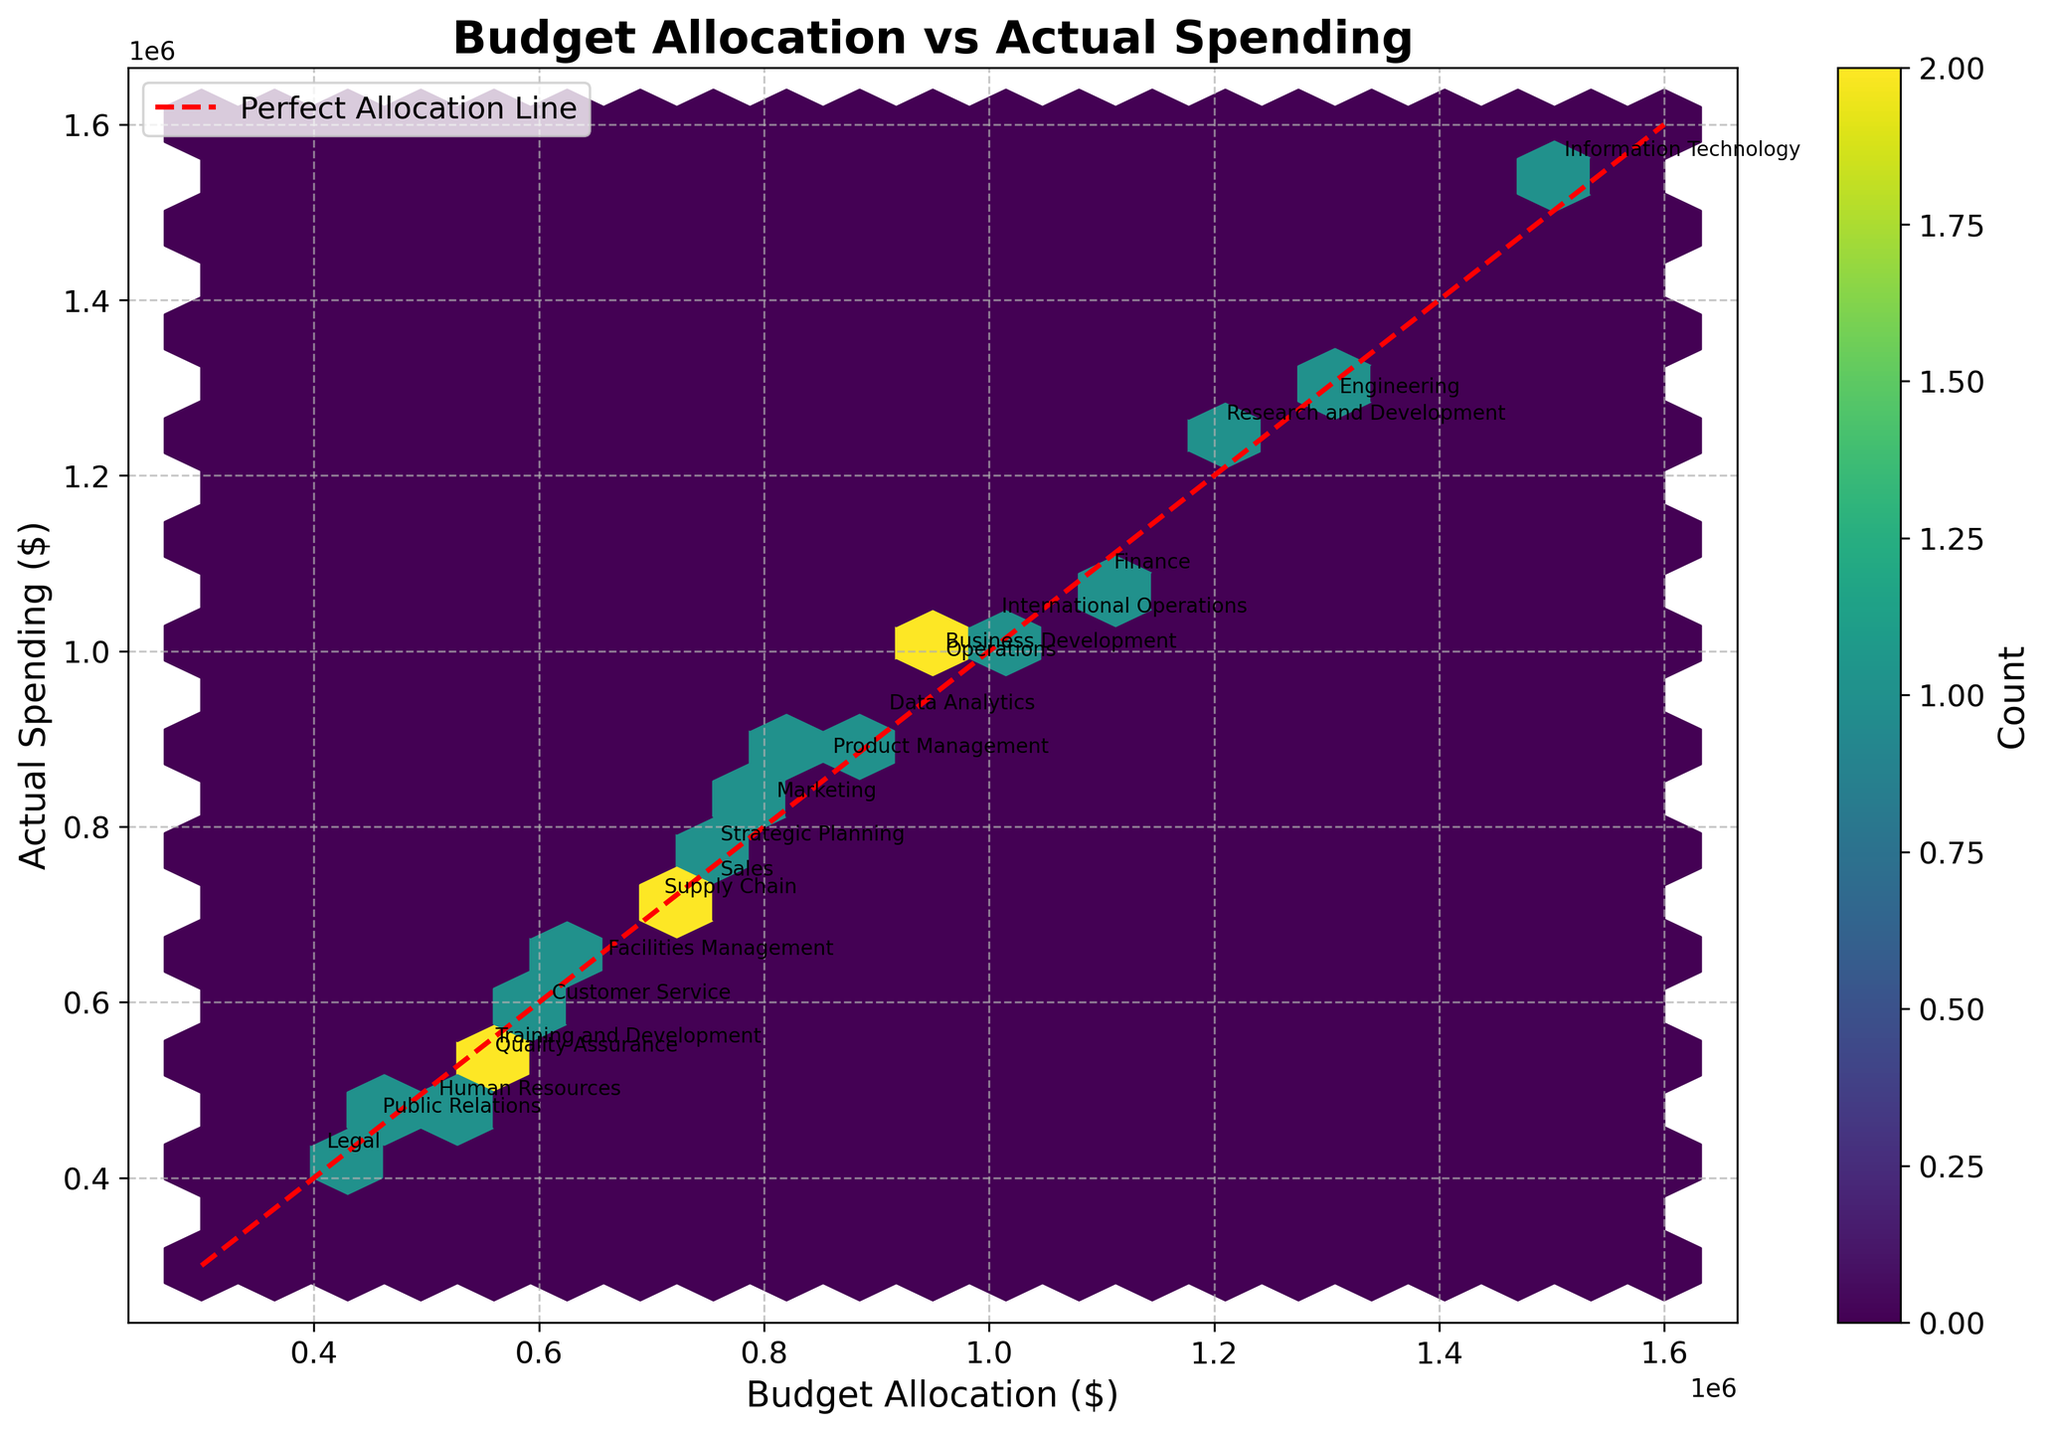What is the title of the plot? The title is displayed at the top of the figure. It provides context about the data being visualized.
Answer: Budget Allocation vs Actual Spending What does the color bar on the right side of the plot represent? The color bar provides a legend for the color intensity in the hexbin plot. It shows the count of data points within each hexbin.
Answer: Count What is the shape of the data points distribution with respect to the perfect allocation line? Observing the data points scattered across the plot, they generally form a cloud around the diagonal dashed red line, which indicates the line where the budget allocation would equal actual spending.
Answer: Spread around the perfect allocation line Which business unit has the highest values for both budget allocation and actual spending? The business unit with the highest values for both axes should appear in the top right corner of the plot. Checking labels, Information Technology has the highest values.
Answer: Information Technology Are there more data points above or below the perfect allocation line, and what does it indicate? By examining the overall density of hexagons, more data points seem to be above the perfect allocation line, indicating that in general, actual spending tends to be higher than budget allocations.
Answer: Above; indicates actual spending exceeds budget Which business unit has the most significant difference between budget allocation and actual spending? To identify the unit, compare the distance of points from the perfect allocation line. Business Development is farther from the line compared to others, indicating a significant difference.
Answer: Business Development Identify the two business units with budget allocations closest to $750,000. Examine the x-axis near $750,000 and look for labels close to this value. Sales and Strategic Planning are the units near that range.
Answer: Sales and Strategic Planning What's the grid size of the hexagons used in the plot? Count the approximate number of hexagons along one axis length considering the provided extent (300,000 to 1,600,000). The grid size parameter set at 20 means there are 20 hexagons along each axis.
Answer: 20 Which hexbin (hexagon) color indicates the highest count of data points? Refer to the color bar legend and observe which color at the highest point on the color bar matches the plot. The most intense color signifies the highest count.
Answer: Dark purple 